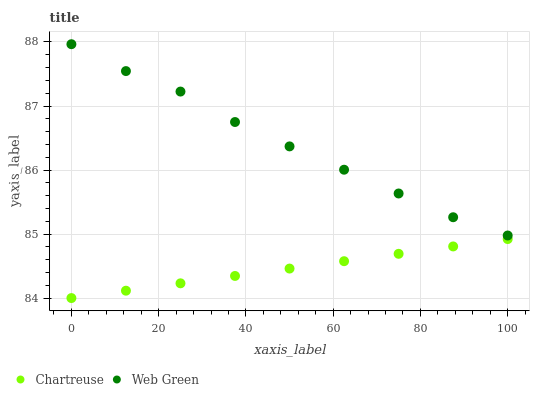Does Chartreuse have the minimum area under the curve?
Answer yes or no. Yes. Does Web Green have the maximum area under the curve?
Answer yes or no. Yes. Does Web Green have the minimum area under the curve?
Answer yes or no. No. Is Chartreuse the smoothest?
Answer yes or no. Yes. Is Web Green the roughest?
Answer yes or no. Yes. Is Web Green the smoothest?
Answer yes or no. No. Does Chartreuse have the lowest value?
Answer yes or no. Yes. Does Web Green have the lowest value?
Answer yes or no. No. Does Web Green have the highest value?
Answer yes or no. Yes. Is Chartreuse less than Web Green?
Answer yes or no. Yes. Is Web Green greater than Chartreuse?
Answer yes or no. Yes. Does Chartreuse intersect Web Green?
Answer yes or no. No. 